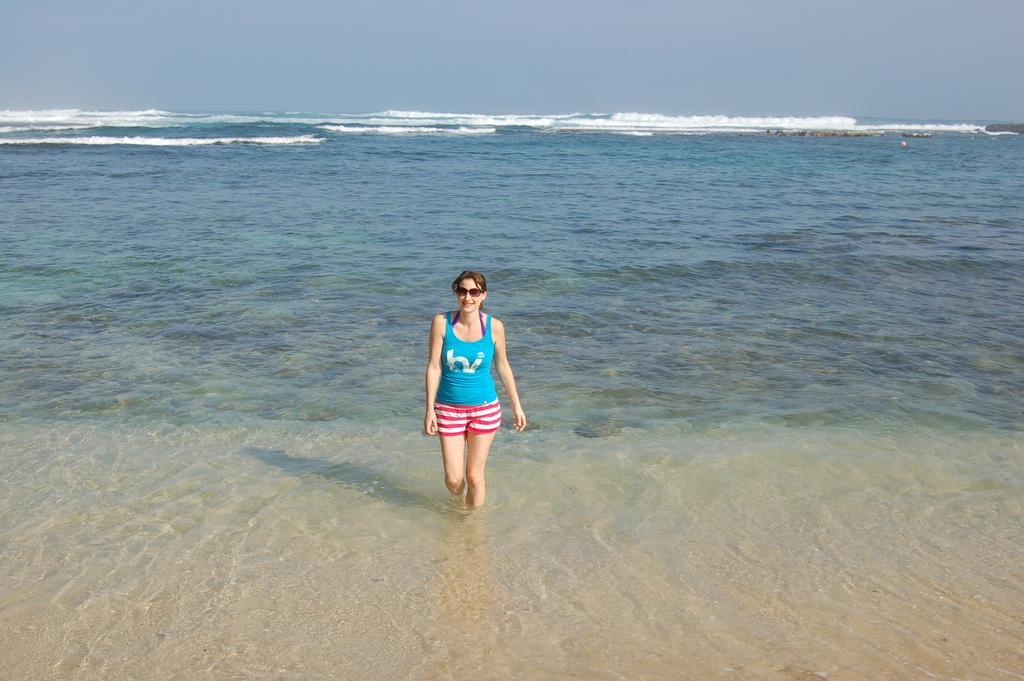Can you describe this image briefly? In the middle we can see a woman. The picture consists of a water body. At the top there is sky. 